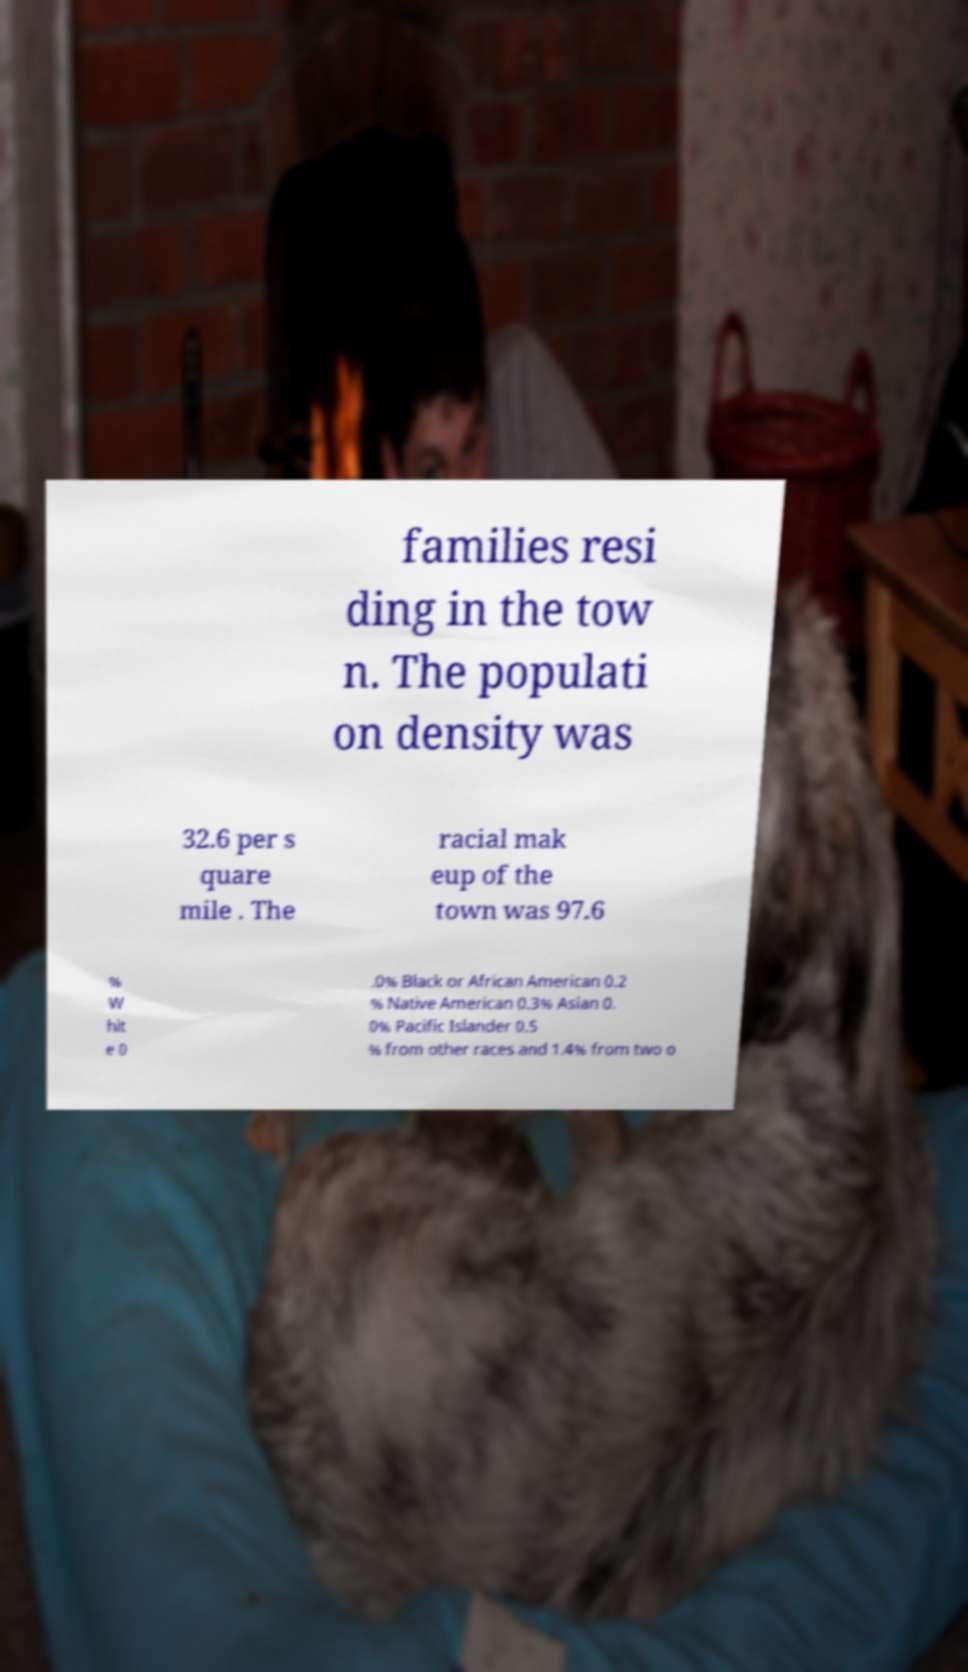For documentation purposes, I need the text within this image transcribed. Could you provide that? families resi ding in the tow n. The populati on density was 32.6 per s quare mile . The racial mak eup of the town was 97.6 % W hit e 0 .0% Black or African American 0.2 % Native American 0.3% Asian 0. 0% Pacific Islander 0.5 % from other races and 1.4% from two o 